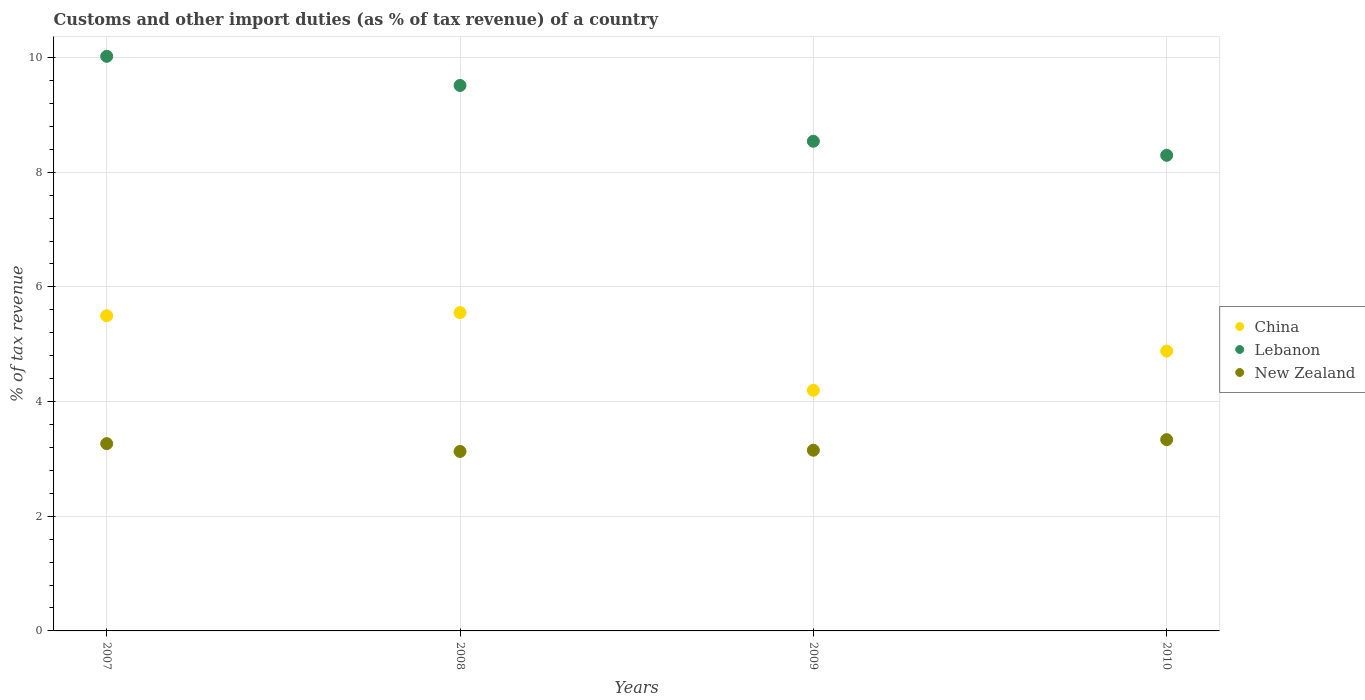How many different coloured dotlines are there?
Offer a very short reply. 3. Is the number of dotlines equal to the number of legend labels?
Make the answer very short. Yes. What is the percentage of tax revenue from customs in New Zealand in 2010?
Ensure brevity in your answer.  3.34. Across all years, what is the maximum percentage of tax revenue from customs in New Zealand?
Give a very brief answer. 3.34. Across all years, what is the minimum percentage of tax revenue from customs in China?
Your answer should be very brief. 4.2. What is the total percentage of tax revenue from customs in China in the graph?
Offer a very short reply. 20.13. What is the difference between the percentage of tax revenue from customs in New Zealand in 2007 and that in 2008?
Offer a terse response. 0.14. What is the difference between the percentage of tax revenue from customs in China in 2008 and the percentage of tax revenue from customs in New Zealand in 2007?
Offer a very short reply. 2.28. What is the average percentage of tax revenue from customs in China per year?
Provide a succinct answer. 5.03. In the year 2010, what is the difference between the percentage of tax revenue from customs in China and percentage of tax revenue from customs in New Zealand?
Offer a very short reply. 1.55. In how many years, is the percentage of tax revenue from customs in China greater than 6 %?
Offer a terse response. 0. What is the ratio of the percentage of tax revenue from customs in New Zealand in 2007 to that in 2010?
Your answer should be very brief. 0.98. Is the percentage of tax revenue from customs in China in 2007 less than that in 2010?
Ensure brevity in your answer.  No. Is the difference between the percentage of tax revenue from customs in China in 2007 and 2009 greater than the difference between the percentage of tax revenue from customs in New Zealand in 2007 and 2009?
Your response must be concise. Yes. What is the difference between the highest and the second highest percentage of tax revenue from customs in New Zealand?
Offer a very short reply. 0.07. What is the difference between the highest and the lowest percentage of tax revenue from customs in China?
Offer a very short reply. 1.36. Is the sum of the percentage of tax revenue from customs in New Zealand in 2008 and 2010 greater than the maximum percentage of tax revenue from customs in Lebanon across all years?
Your response must be concise. No. Is it the case that in every year, the sum of the percentage of tax revenue from customs in New Zealand and percentage of tax revenue from customs in Lebanon  is greater than the percentage of tax revenue from customs in China?
Make the answer very short. Yes. Is the percentage of tax revenue from customs in China strictly greater than the percentage of tax revenue from customs in New Zealand over the years?
Your answer should be very brief. Yes. Is the percentage of tax revenue from customs in China strictly less than the percentage of tax revenue from customs in New Zealand over the years?
Your answer should be compact. No. How many dotlines are there?
Your response must be concise. 3. Are the values on the major ticks of Y-axis written in scientific E-notation?
Keep it short and to the point. No. Does the graph contain grids?
Your answer should be very brief. Yes. Where does the legend appear in the graph?
Offer a very short reply. Center right. How many legend labels are there?
Your answer should be very brief. 3. What is the title of the graph?
Keep it short and to the point. Customs and other import duties (as % of tax revenue) of a country. What is the label or title of the X-axis?
Provide a short and direct response. Years. What is the label or title of the Y-axis?
Ensure brevity in your answer.  % of tax revenue. What is the % of tax revenue in China in 2007?
Keep it short and to the point. 5.5. What is the % of tax revenue of Lebanon in 2007?
Offer a terse response. 10.02. What is the % of tax revenue of New Zealand in 2007?
Make the answer very short. 3.27. What is the % of tax revenue in China in 2008?
Ensure brevity in your answer.  5.55. What is the % of tax revenue of Lebanon in 2008?
Make the answer very short. 9.51. What is the % of tax revenue of New Zealand in 2008?
Provide a succinct answer. 3.13. What is the % of tax revenue in China in 2009?
Offer a very short reply. 4.2. What is the % of tax revenue of Lebanon in 2009?
Make the answer very short. 8.54. What is the % of tax revenue in New Zealand in 2009?
Keep it short and to the point. 3.15. What is the % of tax revenue in China in 2010?
Provide a succinct answer. 4.88. What is the % of tax revenue in Lebanon in 2010?
Provide a succinct answer. 8.3. What is the % of tax revenue of New Zealand in 2010?
Ensure brevity in your answer.  3.34. Across all years, what is the maximum % of tax revenue in China?
Offer a terse response. 5.55. Across all years, what is the maximum % of tax revenue of Lebanon?
Your answer should be very brief. 10.02. Across all years, what is the maximum % of tax revenue of New Zealand?
Offer a terse response. 3.34. Across all years, what is the minimum % of tax revenue in China?
Provide a short and direct response. 4.2. Across all years, what is the minimum % of tax revenue of Lebanon?
Your answer should be compact. 8.3. Across all years, what is the minimum % of tax revenue of New Zealand?
Offer a terse response. 3.13. What is the total % of tax revenue of China in the graph?
Ensure brevity in your answer.  20.13. What is the total % of tax revenue of Lebanon in the graph?
Keep it short and to the point. 36.37. What is the total % of tax revenue of New Zealand in the graph?
Your response must be concise. 12.88. What is the difference between the % of tax revenue in China in 2007 and that in 2008?
Ensure brevity in your answer.  -0.05. What is the difference between the % of tax revenue of Lebanon in 2007 and that in 2008?
Your response must be concise. 0.51. What is the difference between the % of tax revenue of New Zealand in 2007 and that in 2008?
Your answer should be very brief. 0.14. What is the difference between the % of tax revenue in China in 2007 and that in 2009?
Your response must be concise. 1.3. What is the difference between the % of tax revenue in Lebanon in 2007 and that in 2009?
Your response must be concise. 1.48. What is the difference between the % of tax revenue in New Zealand in 2007 and that in 2009?
Your answer should be very brief. 0.11. What is the difference between the % of tax revenue in China in 2007 and that in 2010?
Keep it short and to the point. 0.62. What is the difference between the % of tax revenue of Lebanon in 2007 and that in 2010?
Your response must be concise. 1.73. What is the difference between the % of tax revenue in New Zealand in 2007 and that in 2010?
Make the answer very short. -0.07. What is the difference between the % of tax revenue in China in 2008 and that in 2009?
Give a very brief answer. 1.36. What is the difference between the % of tax revenue in Lebanon in 2008 and that in 2009?
Make the answer very short. 0.97. What is the difference between the % of tax revenue of New Zealand in 2008 and that in 2009?
Keep it short and to the point. -0.02. What is the difference between the % of tax revenue in China in 2008 and that in 2010?
Give a very brief answer. 0.67. What is the difference between the % of tax revenue of Lebanon in 2008 and that in 2010?
Your answer should be very brief. 1.22. What is the difference between the % of tax revenue in New Zealand in 2008 and that in 2010?
Offer a very short reply. -0.21. What is the difference between the % of tax revenue in China in 2009 and that in 2010?
Ensure brevity in your answer.  -0.69. What is the difference between the % of tax revenue in Lebanon in 2009 and that in 2010?
Make the answer very short. 0.25. What is the difference between the % of tax revenue in New Zealand in 2009 and that in 2010?
Offer a terse response. -0.18. What is the difference between the % of tax revenue in China in 2007 and the % of tax revenue in Lebanon in 2008?
Provide a succinct answer. -4.02. What is the difference between the % of tax revenue of China in 2007 and the % of tax revenue of New Zealand in 2008?
Offer a terse response. 2.37. What is the difference between the % of tax revenue in Lebanon in 2007 and the % of tax revenue in New Zealand in 2008?
Provide a short and direct response. 6.89. What is the difference between the % of tax revenue of China in 2007 and the % of tax revenue of Lebanon in 2009?
Make the answer very short. -3.04. What is the difference between the % of tax revenue of China in 2007 and the % of tax revenue of New Zealand in 2009?
Keep it short and to the point. 2.35. What is the difference between the % of tax revenue in Lebanon in 2007 and the % of tax revenue in New Zealand in 2009?
Your answer should be very brief. 6.87. What is the difference between the % of tax revenue in China in 2007 and the % of tax revenue in Lebanon in 2010?
Make the answer very short. -2.8. What is the difference between the % of tax revenue of China in 2007 and the % of tax revenue of New Zealand in 2010?
Provide a succinct answer. 2.16. What is the difference between the % of tax revenue in Lebanon in 2007 and the % of tax revenue in New Zealand in 2010?
Your answer should be compact. 6.69. What is the difference between the % of tax revenue of China in 2008 and the % of tax revenue of Lebanon in 2009?
Offer a very short reply. -2.99. What is the difference between the % of tax revenue in China in 2008 and the % of tax revenue in New Zealand in 2009?
Your answer should be very brief. 2.4. What is the difference between the % of tax revenue in Lebanon in 2008 and the % of tax revenue in New Zealand in 2009?
Offer a very short reply. 6.36. What is the difference between the % of tax revenue in China in 2008 and the % of tax revenue in Lebanon in 2010?
Give a very brief answer. -2.74. What is the difference between the % of tax revenue of China in 2008 and the % of tax revenue of New Zealand in 2010?
Offer a very short reply. 2.21. What is the difference between the % of tax revenue in Lebanon in 2008 and the % of tax revenue in New Zealand in 2010?
Make the answer very short. 6.18. What is the difference between the % of tax revenue of China in 2009 and the % of tax revenue of Lebanon in 2010?
Offer a terse response. -4.1. What is the difference between the % of tax revenue of China in 2009 and the % of tax revenue of New Zealand in 2010?
Give a very brief answer. 0.86. What is the difference between the % of tax revenue in Lebanon in 2009 and the % of tax revenue in New Zealand in 2010?
Provide a short and direct response. 5.2. What is the average % of tax revenue in China per year?
Provide a short and direct response. 5.03. What is the average % of tax revenue in Lebanon per year?
Offer a very short reply. 9.09. What is the average % of tax revenue in New Zealand per year?
Make the answer very short. 3.22. In the year 2007, what is the difference between the % of tax revenue of China and % of tax revenue of Lebanon?
Give a very brief answer. -4.52. In the year 2007, what is the difference between the % of tax revenue of China and % of tax revenue of New Zealand?
Give a very brief answer. 2.23. In the year 2007, what is the difference between the % of tax revenue of Lebanon and % of tax revenue of New Zealand?
Ensure brevity in your answer.  6.76. In the year 2008, what is the difference between the % of tax revenue of China and % of tax revenue of Lebanon?
Make the answer very short. -3.96. In the year 2008, what is the difference between the % of tax revenue in China and % of tax revenue in New Zealand?
Keep it short and to the point. 2.42. In the year 2008, what is the difference between the % of tax revenue of Lebanon and % of tax revenue of New Zealand?
Provide a short and direct response. 6.38. In the year 2009, what is the difference between the % of tax revenue in China and % of tax revenue in Lebanon?
Ensure brevity in your answer.  -4.34. In the year 2009, what is the difference between the % of tax revenue in China and % of tax revenue in New Zealand?
Offer a very short reply. 1.04. In the year 2009, what is the difference between the % of tax revenue in Lebanon and % of tax revenue in New Zealand?
Keep it short and to the point. 5.39. In the year 2010, what is the difference between the % of tax revenue of China and % of tax revenue of Lebanon?
Your response must be concise. -3.41. In the year 2010, what is the difference between the % of tax revenue in China and % of tax revenue in New Zealand?
Your response must be concise. 1.55. In the year 2010, what is the difference between the % of tax revenue of Lebanon and % of tax revenue of New Zealand?
Ensure brevity in your answer.  4.96. What is the ratio of the % of tax revenue of China in 2007 to that in 2008?
Your answer should be compact. 0.99. What is the ratio of the % of tax revenue of Lebanon in 2007 to that in 2008?
Give a very brief answer. 1.05. What is the ratio of the % of tax revenue of New Zealand in 2007 to that in 2008?
Provide a short and direct response. 1.04. What is the ratio of the % of tax revenue in China in 2007 to that in 2009?
Provide a short and direct response. 1.31. What is the ratio of the % of tax revenue in Lebanon in 2007 to that in 2009?
Offer a terse response. 1.17. What is the ratio of the % of tax revenue in New Zealand in 2007 to that in 2009?
Provide a short and direct response. 1.04. What is the ratio of the % of tax revenue in China in 2007 to that in 2010?
Ensure brevity in your answer.  1.13. What is the ratio of the % of tax revenue in Lebanon in 2007 to that in 2010?
Your answer should be very brief. 1.21. What is the ratio of the % of tax revenue of New Zealand in 2007 to that in 2010?
Your answer should be very brief. 0.98. What is the ratio of the % of tax revenue of China in 2008 to that in 2009?
Offer a very short reply. 1.32. What is the ratio of the % of tax revenue in Lebanon in 2008 to that in 2009?
Keep it short and to the point. 1.11. What is the ratio of the % of tax revenue of New Zealand in 2008 to that in 2009?
Provide a succinct answer. 0.99. What is the ratio of the % of tax revenue in China in 2008 to that in 2010?
Offer a very short reply. 1.14. What is the ratio of the % of tax revenue of Lebanon in 2008 to that in 2010?
Provide a succinct answer. 1.15. What is the ratio of the % of tax revenue in New Zealand in 2008 to that in 2010?
Provide a short and direct response. 0.94. What is the ratio of the % of tax revenue of China in 2009 to that in 2010?
Offer a very short reply. 0.86. What is the ratio of the % of tax revenue of Lebanon in 2009 to that in 2010?
Your response must be concise. 1.03. What is the ratio of the % of tax revenue in New Zealand in 2009 to that in 2010?
Keep it short and to the point. 0.94. What is the difference between the highest and the second highest % of tax revenue in China?
Provide a succinct answer. 0.05. What is the difference between the highest and the second highest % of tax revenue of Lebanon?
Make the answer very short. 0.51. What is the difference between the highest and the second highest % of tax revenue in New Zealand?
Your answer should be compact. 0.07. What is the difference between the highest and the lowest % of tax revenue in China?
Provide a short and direct response. 1.36. What is the difference between the highest and the lowest % of tax revenue of Lebanon?
Keep it short and to the point. 1.73. What is the difference between the highest and the lowest % of tax revenue of New Zealand?
Offer a terse response. 0.21. 